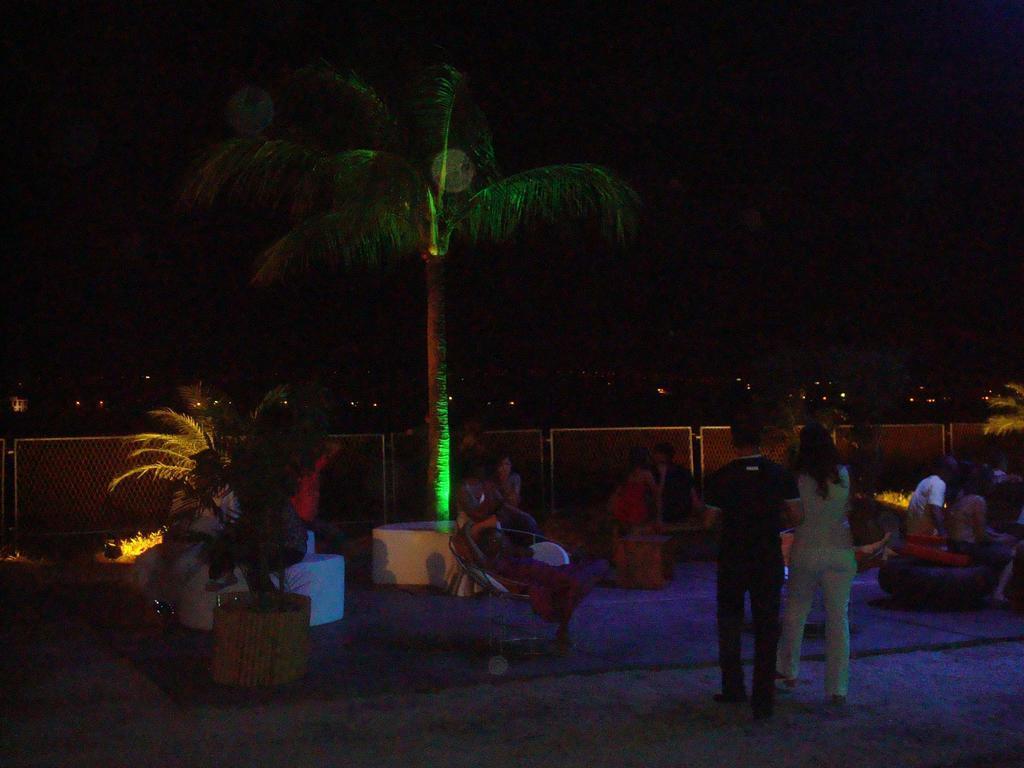Describe this image in one or two sentences. In this image I can see group of people, some are sitting and some are standing. In the background I can see few plants and trees in green color, few lights and I can also see the railing. 